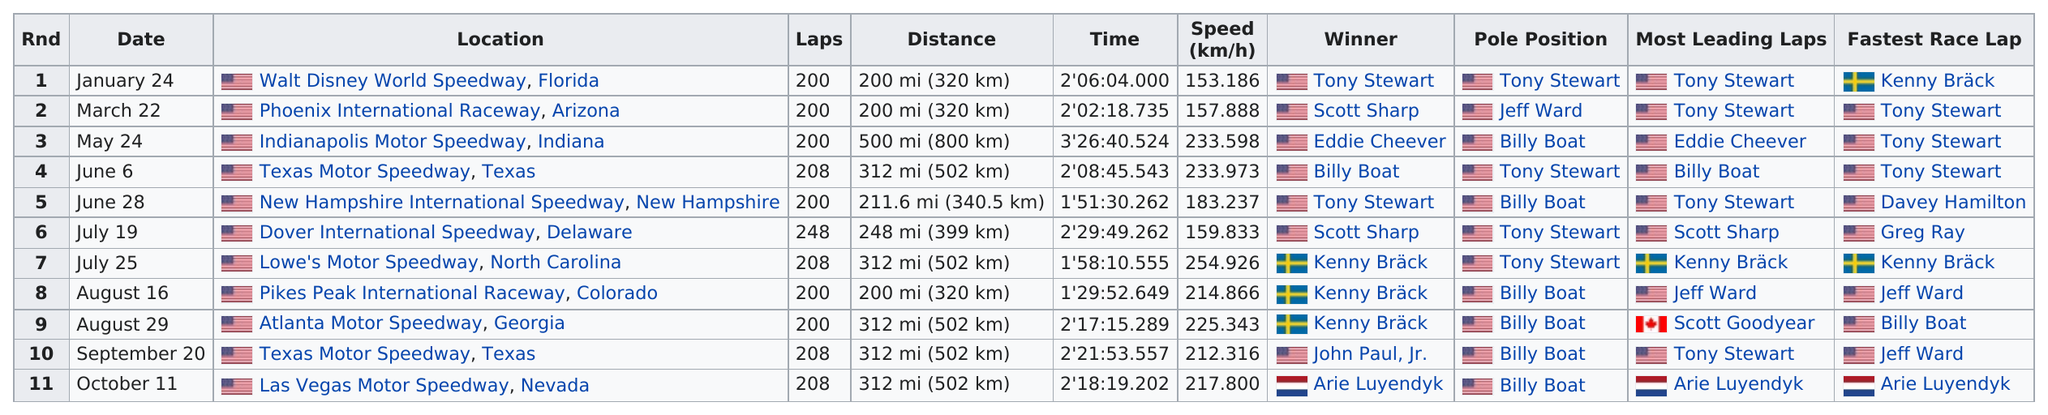Mention a couple of crucial points in this snapshot. The difference between the fastest and slowest speed during the year was 101.74 meters per hour. Tony Stewart holds the distinction of finishing the fastest in races other than Texas Motor Speedway, at Phoenix International Raceway in Arizona, and at Indianapolis Motor Speedway in Indiana. The race held at Texas Motor Speedway consisted of 208 laps. I hereby declare that Walt Disney World Speedway in Florida is the only location that has a distance of 200 miles. It is Arie Luyendyk, the only Frenchman, who has won during the year. 